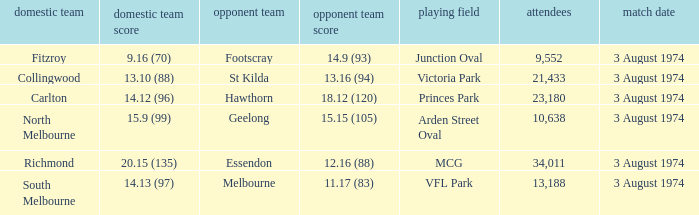Which Venue has a Home team score of 9.16 (70)? Junction Oval. 